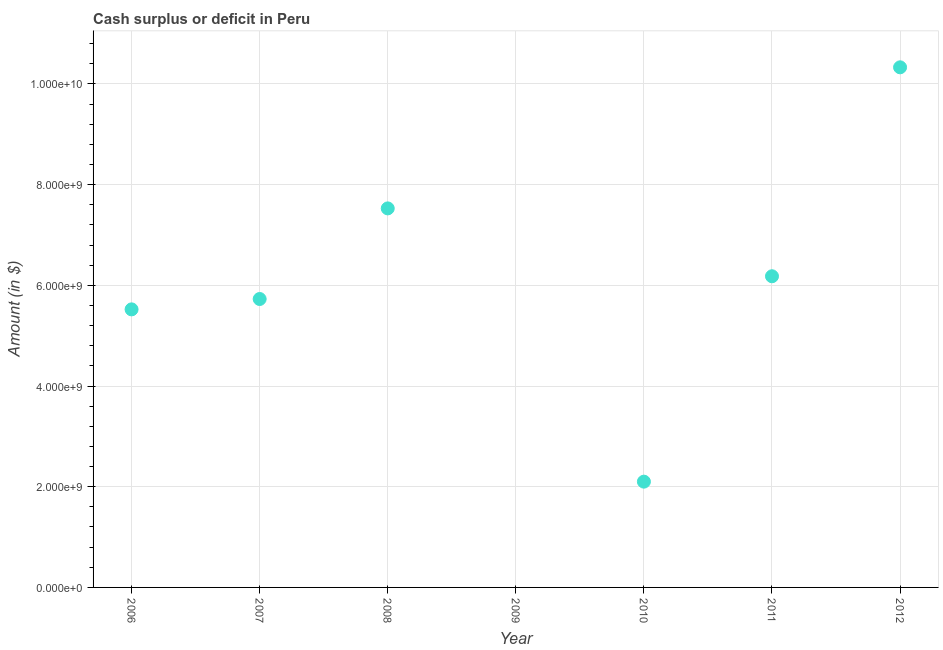What is the cash surplus or deficit in 2007?
Ensure brevity in your answer.  5.73e+09. Across all years, what is the maximum cash surplus or deficit?
Your response must be concise. 1.03e+1. In which year was the cash surplus or deficit maximum?
Your answer should be compact. 2012. What is the sum of the cash surplus or deficit?
Your answer should be compact. 3.74e+1. What is the difference between the cash surplus or deficit in 2010 and 2012?
Your response must be concise. -8.23e+09. What is the average cash surplus or deficit per year?
Ensure brevity in your answer.  5.34e+09. What is the median cash surplus or deficit?
Offer a terse response. 5.73e+09. What is the ratio of the cash surplus or deficit in 2006 to that in 2008?
Offer a very short reply. 0.73. Is the cash surplus or deficit in 2007 less than that in 2011?
Your answer should be compact. Yes. What is the difference between the highest and the second highest cash surplus or deficit?
Ensure brevity in your answer.  2.80e+09. Is the sum of the cash surplus or deficit in 2008 and 2010 greater than the maximum cash surplus or deficit across all years?
Your response must be concise. No. What is the difference between the highest and the lowest cash surplus or deficit?
Offer a very short reply. 1.03e+1. In how many years, is the cash surplus or deficit greater than the average cash surplus or deficit taken over all years?
Keep it short and to the point. 5. What is the difference between two consecutive major ticks on the Y-axis?
Make the answer very short. 2.00e+09. Are the values on the major ticks of Y-axis written in scientific E-notation?
Your answer should be compact. Yes. Does the graph contain any zero values?
Keep it short and to the point. Yes. What is the title of the graph?
Provide a short and direct response. Cash surplus or deficit in Peru. What is the label or title of the Y-axis?
Your answer should be very brief. Amount (in $). What is the Amount (in $) in 2006?
Your response must be concise. 5.52e+09. What is the Amount (in $) in 2007?
Your response must be concise. 5.73e+09. What is the Amount (in $) in 2008?
Your response must be concise. 7.53e+09. What is the Amount (in $) in 2010?
Your answer should be very brief. 2.10e+09. What is the Amount (in $) in 2011?
Provide a short and direct response. 6.18e+09. What is the Amount (in $) in 2012?
Your answer should be compact. 1.03e+1. What is the difference between the Amount (in $) in 2006 and 2007?
Your answer should be compact. -2.06e+08. What is the difference between the Amount (in $) in 2006 and 2008?
Offer a terse response. -2.01e+09. What is the difference between the Amount (in $) in 2006 and 2010?
Give a very brief answer. 3.42e+09. What is the difference between the Amount (in $) in 2006 and 2011?
Provide a short and direct response. -6.57e+08. What is the difference between the Amount (in $) in 2006 and 2012?
Provide a succinct answer. -4.81e+09. What is the difference between the Amount (in $) in 2007 and 2008?
Your answer should be very brief. -1.80e+09. What is the difference between the Amount (in $) in 2007 and 2010?
Your answer should be compact. 3.63e+09. What is the difference between the Amount (in $) in 2007 and 2011?
Offer a very short reply. -4.52e+08. What is the difference between the Amount (in $) in 2007 and 2012?
Keep it short and to the point. -4.60e+09. What is the difference between the Amount (in $) in 2008 and 2010?
Your answer should be very brief. 5.43e+09. What is the difference between the Amount (in $) in 2008 and 2011?
Provide a short and direct response. 1.35e+09. What is the difference between the Amount (in $) in 2008 and 2012?
Your answer should be compact. -2.80e+09. What is the difference between the Amount (in $) in 2010 and 2011?
Provide a succinct answer. -4.08e+09. What is the difference between the Amount (in $) in 2010 and 2012?
Ensure brevity in your answer.  -8.23e+09. What is the difference between the Amount (in $) in 2011 and 2012?
Give a very brief answer. -4.15e+09. What is the ratio of the Amount (in $) in 2006 to that in 2007?
Offer a terse response. 0.96. What is the ratio of the Amount (in $) in 2006 to that in 2008?
Ensure brevity in your answer.  0.73. What is the ratio of the Amount (in $) in 2006 to that in 2010?
Provide a succinct answer. 2.63. What is the ratio of the Amount (in $) in 2006 to that in 2011?
Provide a short and direct response. 0.89. What is the ratio of the Amount (in $) in 2006 to that in 2012?
Offer a very short reply. 0.54. What is the ratio of the Amount (in $) in 2007 to that in 2008?
Your answer should be compact. 0.76. What is the ratio of the Amount (in $) in 2007 to that in 2010?
Ensure brevity in your answer.  2.73. What is the ratio of the Amount (in $) in 2007 to that in 2011?
Give a very brief answer. 0.93. What is the ratio of the Amount (in $) in 2007 to that in 2012?
Your response must be concise. 0.56. What is the ratio of the Amount (in $) in 2008 to that in 2010?
Offer a very short reply. 3.58. What is the ratio of the Amount (in $) in 2008 to that in 2011?
Offer a terse response. 1.22. What is the ratio of the Amount (in $) in 2008 to that in 2012?
Your answer should be very brief. 0.73. What is the ratio of the Amount (in $) in 2010 to that in 2011?
Provide a short and direct response. 0.34. What is the ratio of the Amount (in $) in 2010 to that in 2012?
Offer a terse response. 0.2. What is the ratio of the Amount (in $) in 2011 to that in 2012?
Your answer should be compact. 0.6. 